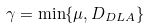Convert formula to latex. <formula><loc_0><loc_0><loc_500><loc_500>\gamma = \min \{ \mu , { D _ { D L A } } \}</formula> 